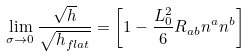<formula> <loc_0><loc_0><loc_500><loc_500>\lim _ { \sigma \to 0 } \frac { \sqrt { h } } { \sqrt { h _ { f l a t } } } = \left [ 1 - \frac { L _ { 0 } ^ { 2 } } { 6 } R _ { a b } n ^ { a } n ^ { b } \right ]</formula> 